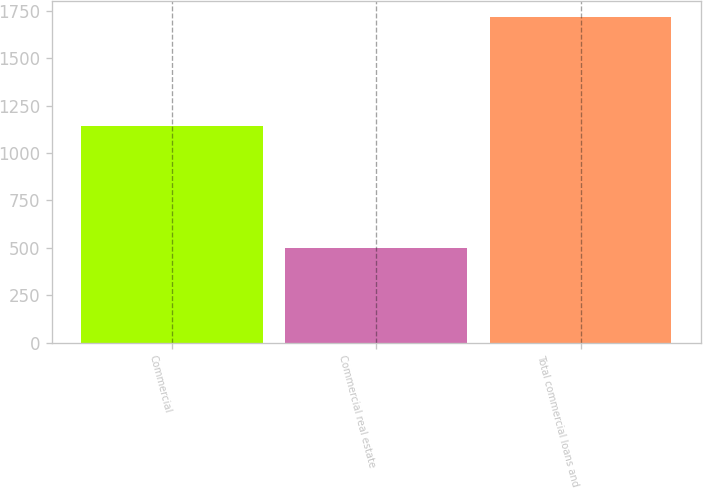<chart> <loc_0><loc_0><loc_500><loc_500><bar_chart><fcel>Commercial<fcel>Commercial real estate<fcel>Total commercial loans and<nl><fcel>1143<fcel>500<fcel>1716<nl></chart> 